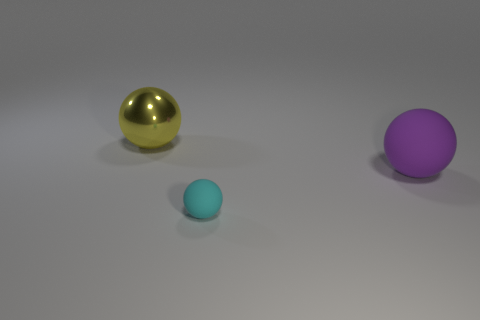Add 1 cyan matte balls. How many objects exist? 4 Add 2 large yellow matte cylinders. How many large yellow matte cylinders exist? 2 Subtract 0 purple cubes. How many objects are left? 3 Subtract all big cyan balls. Subtract all metallic things. How many objects are left? 2 Add 1 tiny spheres. How many tiny spheres are left? 2 